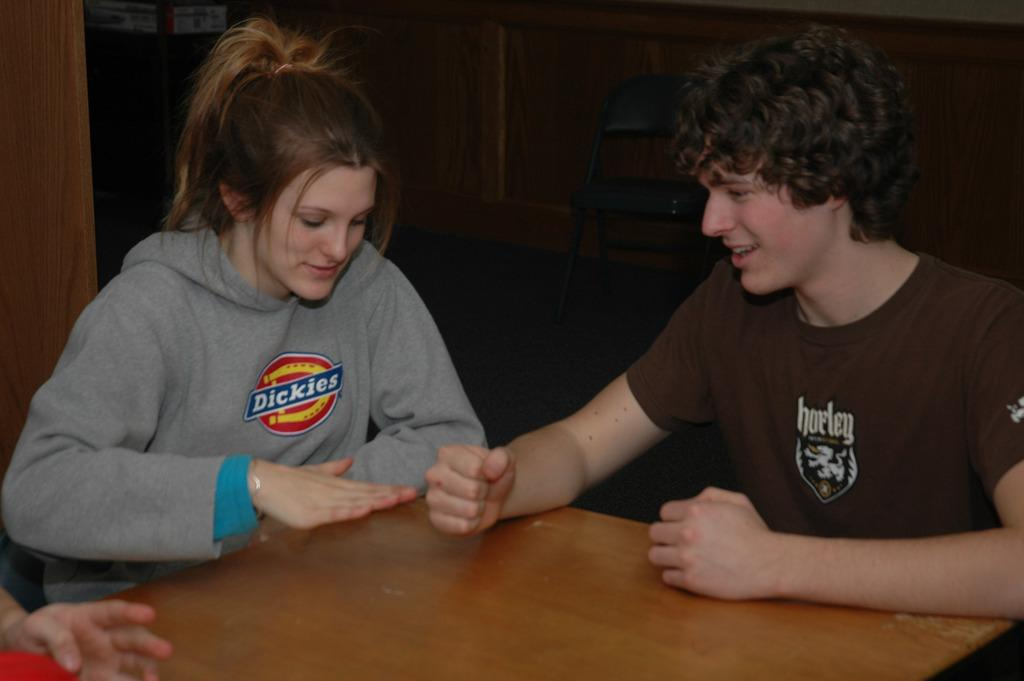How many people are in the image? There are two people in the image, a man and a woman. What are the man and woman doing in the image? Both the man and woman are sitting beside a table. What can be seen in the background of the image? There is a chair and a wall visible in the background. Whose hand is visible in the left bottom of the image? It is not specified whose hand is visible in the image, but it belongs to one of the people present. What type of brass instrument is the man playing in the image? There is no brass instrument present in the image; the man and woman are sitting beside a table. What color are the jeans worn by the woman in the image? There is no mention of jeans or any specific clothing worn by the woman in the image. 